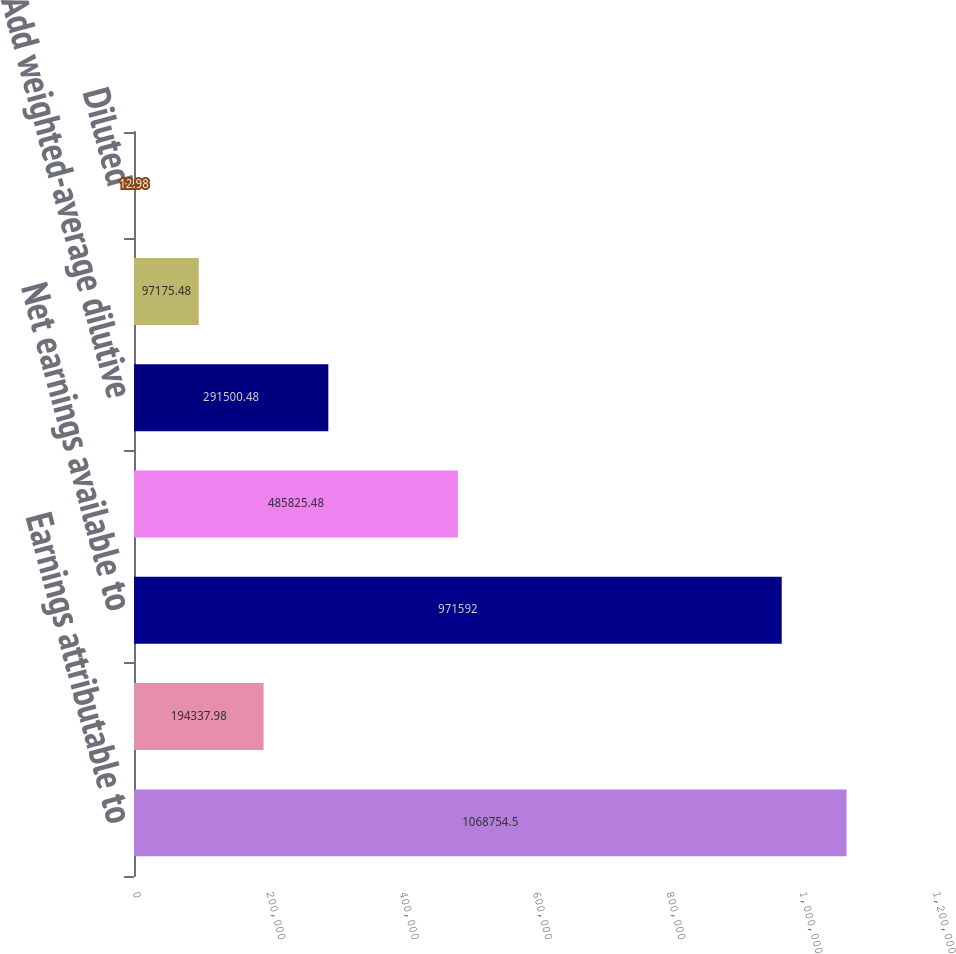Convert chart to OTSL. <chart><loc_0><loc_0><loc_500><loc_500><bar_chart><fcel>Earnings attributable to<fcel>Accretion of redeemable<fcel>Net earnings available to<fcel>Weighted-average common shares<fcel>Add weighted-average dilutive<fcel>Basic<fcel>Diluted<nl><fcel>1.06875e+06<fcel>194338<fcel>971592<fcel>485825<fcel>291500<fcel>97175.5<fcel>12.98<nl></chart> 